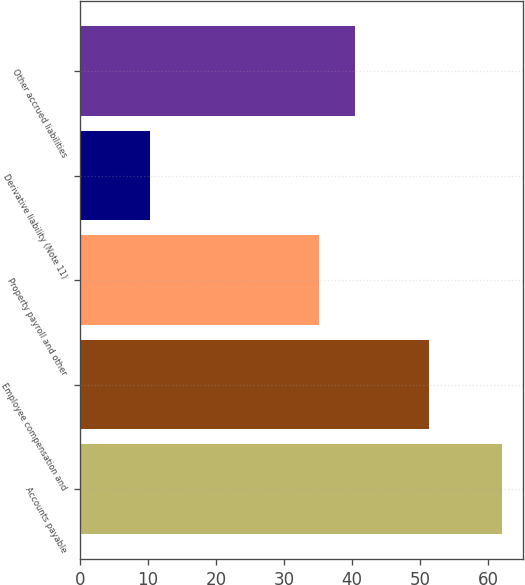<chart> <loc_0><loc_0><loc_500><loc_500><bar_chart><fcel>Accounts payable<fcel>Employee compensation and<fcel>Property payroll and other<fcel>Derivative liability (Note 11)<fcel>Other accrued liabilities<nl><fcel>62<fcel>51.3<fcel>35.2<fcel>10.3<fcel>40.37<nl></chart> 